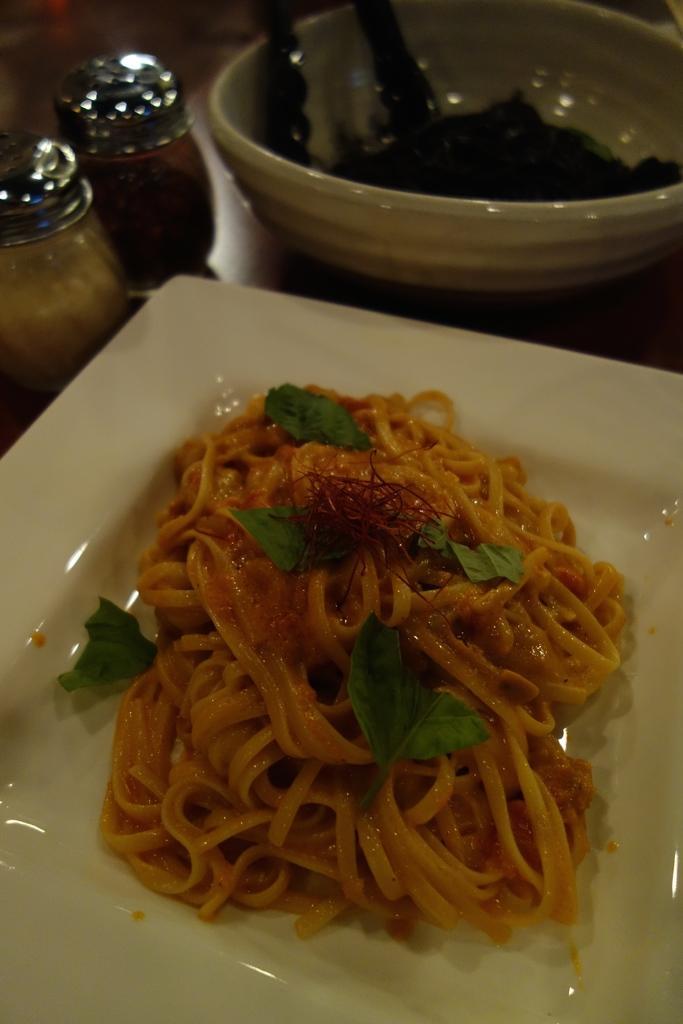In one or two sentences, can you explain what this image depicts? In this picture I can see food in the plate and some food in the bowl. I can see salt and pepper shakers on the table. 